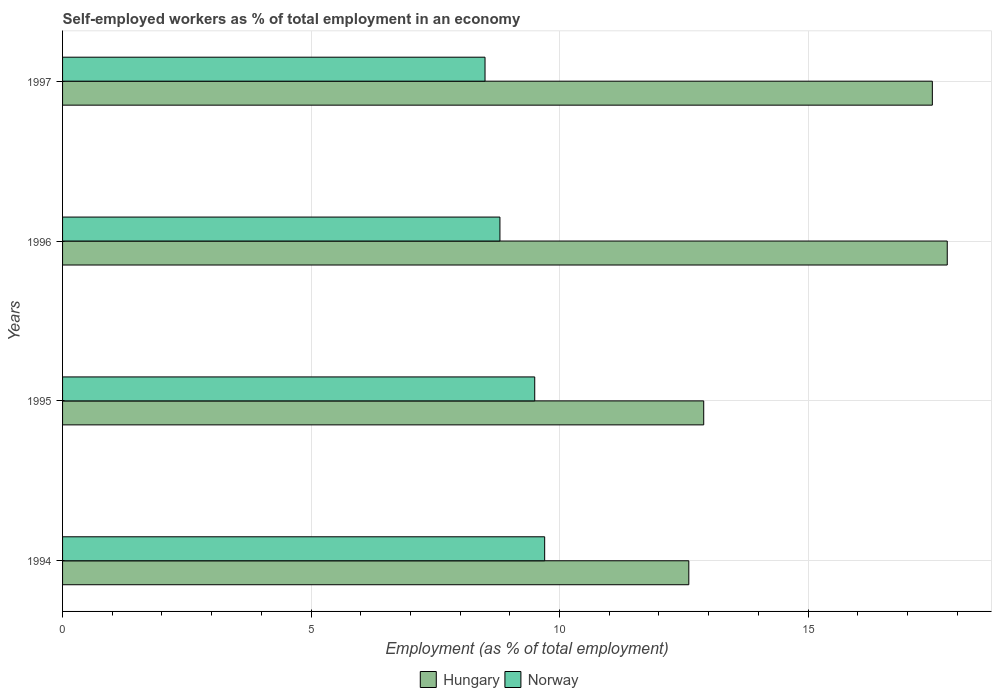How many different coloured bars are there?
Offer a terse response. 2. How many groups of bars are there?
Your answer should be compact. 4. Are the number of bars per tick equal to the number of legend labels?
Give a very brief answer. Yes. How many bars are there on the 3rd tick from the top?
Your answer should be compact. 2. What is the label of the 1st group of bars from the top?
Offer a terse response. 1997. In how many cases, is the number of bars for a given year not equal to the number of legend labels?
Make the answer very short. 0. What is the percentage of self-employed workers in Norway in 1997?
Provide a succinct answer. 8.5. Across all years, what is the maximum percentage of self-employed workers in Norway?
Offer a terse response. 9.7. In which year was the percentage of self-employed workers in Norway maximum?
Your answer should be compact. 1994. In which year was the percentage of self-employed workers in Norway minimum?
Offer a very short reply. 1997. What is the total percentage of self-employed workers in Hungary in the graph?
Make the answer very short. 60.8. What is the difference between the percentage of self-employed workers in Hungary in 1996 and that in 1997?
Your answer should be compact. 0.3. What is the difference between the percentage of self-employed workers in Hungary in 1995 and the percentage of self-employed workers in Norway in 1997?
Your response must be concise. 4.4. What is the average percentage of self-employed workers in Norway per year?
Ensure brevity in your answer.  9.12. In the year 1995, what is the difference between the percentage of self-employed workers in Norway and percentage of self-employed workers in Hungary?
Make the answer very short. -3.4. In how many years, is the percentage of self-employed workers in Hungary greater than 9 %?
Make the answer very short. 4. What is the ratio of the percentage of self-employed workers in Hungary in 1995 to that in 1996?
Provide a succinct answer. 0.72. Is the difference between the percentage of self-employed workers in Norway in 1995 and 1996 greater than the difference between the percentage of self-employed workers in Hungary in 1995 and 1996?
Make the answer very short. Yes. What is the difference between the highest and the second highest percentage of self-employed workers in Norway?
Provide a short and direct response. 0.2. What is the difference between the highest and the lowest percentage of self-employed workers in Hungary?
Provide a succinct answer. 5.2. How many bars are there?
Your answer should be very brief. 8. Are all the bars in the graph horizontal?
Ensure brevity in your answer.  Yes. What is the difference between two consecutive major ticks on the X-axis?
Give a very brief answer. 5. Are the values on the major ticks of X-axis written in scientific E-notation?
Provide a short and direct response. No. How many legend labels are there?
Provide a succinct answer. 2. How are the legend labels stacked?
Make the answer very short. Horizontal. What is the title of the graph?
Give a very brief answer. Self-employed workers as % of total employment in an economy. What is the label or title of the X-axis?
Give a very brief answer. Employment (as % of total employment). What is the Employment (as % of total employment) in Hungary in 1994?
Make the answer very short. 12.6. What is the Employment (as % of total employment) of Norway in 1994?
Provide a short and direct response. 9.7. What is the Employment (as % of total employment) of Hungary in 1995?
Keep it short and to the point. 12.9. What is the Employment (as % of total employment) of Norway in 1995?
Keep it short and to the point. 9.5. What is the Employment (as % of total employment) of Hungary in 1996?
Provide a succinct answer. 17.8. What is the Employment (as % of total employment) in Norway in 1996?
Offer a very short reply. 8.8. What is the Employment (as % of total employment) of Hungary in 1997?
Ensure brevity in your answer.  17.5. Across all years, what is the maximum Employment (as % of total employment) in Hungary?
Provide a succinct answer. 17.8. Across all years, what is the maximum Employment (as % of total employment) of Norway?
Provide a succinct answer. 9.7. Across all years, what is the minimum Employment (as % of total employment) in Hungary?
Make the answer very short. 12.6. Across all years, what is the minimum Employment (as % of total employment) in Norway?
Ensure brevity in your answer.  8.5. What is the total Employment (as % of total employment) of Hungary in the graph?
Offer a very short reply. 60.8. What is the total Employment (as % of total employment) of Norway in the graph?
Offer a very short reply. 36.5. What is the difference between the Employment (as % of total employment) of Norway in 1994 and that in 1995?
Provide a succinct answer. 0.2. What is the difference between the Employment (as % of total employment) of Norway in 1994 and that in 1996?
Your response must be concise. 0.9. What is the difference between the Employment (as % of total employment) in Hungary in 1994 and that in 1997?
Offer a terse response. -4.9. What is the difference between the Employment (as % of total employment) in Hungary in 1995 and that in 1997?
Provide a short and direct response. -4.6. What is the difference between the Employment (as % of total employment) in Norway in 1995 and that in 1997?
Keep it short and to the point. 1. What is the difference between the Employment (as % of total employment) of Hungary in 1994 and the Employment (as % of total employment) of Norway in 1995?
Offer a terse response. 3.1. What is the average Employment (as % of total employment) of Hungary per year?
Give a very brief answer. 15.2. What is the average Employment (as % of total employment) of Norway per year?
Offer a very short reply. 9.12. In the year 1994, what is the difference between the Employment (as % of total employment) of Hungary and Employment (as % of total employment) of Norway?
Ensure brevity in your answer.  2.9. In the year 1997, what is the difference between the Employment (as % of total employment) in Hungary and Employment (as % of total employment) in Norway?
Provide a short and direct response. 9. What is the ratio of the Employment (as % of total employment) in Hungary in 1994 to that in 1995?
Your answer should be compact. 0.98. What is the ratio of the Employment (as % of total employment) in Norway in 1994 to that in 1995?
Offer a terse response. 1.02. What is the ratio of the Employment (as % of total employment) in Hungary in 1994 to that in 1996?
Your answer should be very brief. 0.71. What is the ratio of the Employment (as % of total employment) in Norway in 1994 to that in 1996?
Keep it short and to the point. 1.1. What is the ratio of the Employment (as % of total employment) in Hungary in 1994 to that in 1997?
Your answer should be very brief. 0.72. What is the ratio of the Employment (as % of total employment) in Norway in 1994 to that in 1997?
Make the answer very short. 1.14. What is the ratio of the Employment (as % of total employment) in Hungary in 1995 to that in 1996?
Your answer should be very brief. 0.72. What is the ratio of the Employment (as % of total employment) of Norway in 1995 to that in 1996?
Offer a terse response. 1.08. What is the ratio of the Employment (as % of total employment) of Hungary in 1995 to that in 1997?
Your answer should be compact. 0.74. What is the ratio of the Employment (as % of total employment) in Norway in 1995 to that in 1997?
Provide a succinct answer. 1.12. What is the ratio of the Employment (as % of total employment) in Hungary in 1996 to that in 1997?
Offer a terse response. 1.02. What is the ratio of the Employment (as % of total employment) in Norway in 1996 to that in 1997?
Give a very brief answer. 1.04. What is the difference between the highest and the lowest Employment (as % of total employment) in Hungary?
Your answer should be compact. 5.2. What is the difference between the highest and the lowest Employment (as % of total employment) of Norway?
Keep it short and to the point. 1.2. 